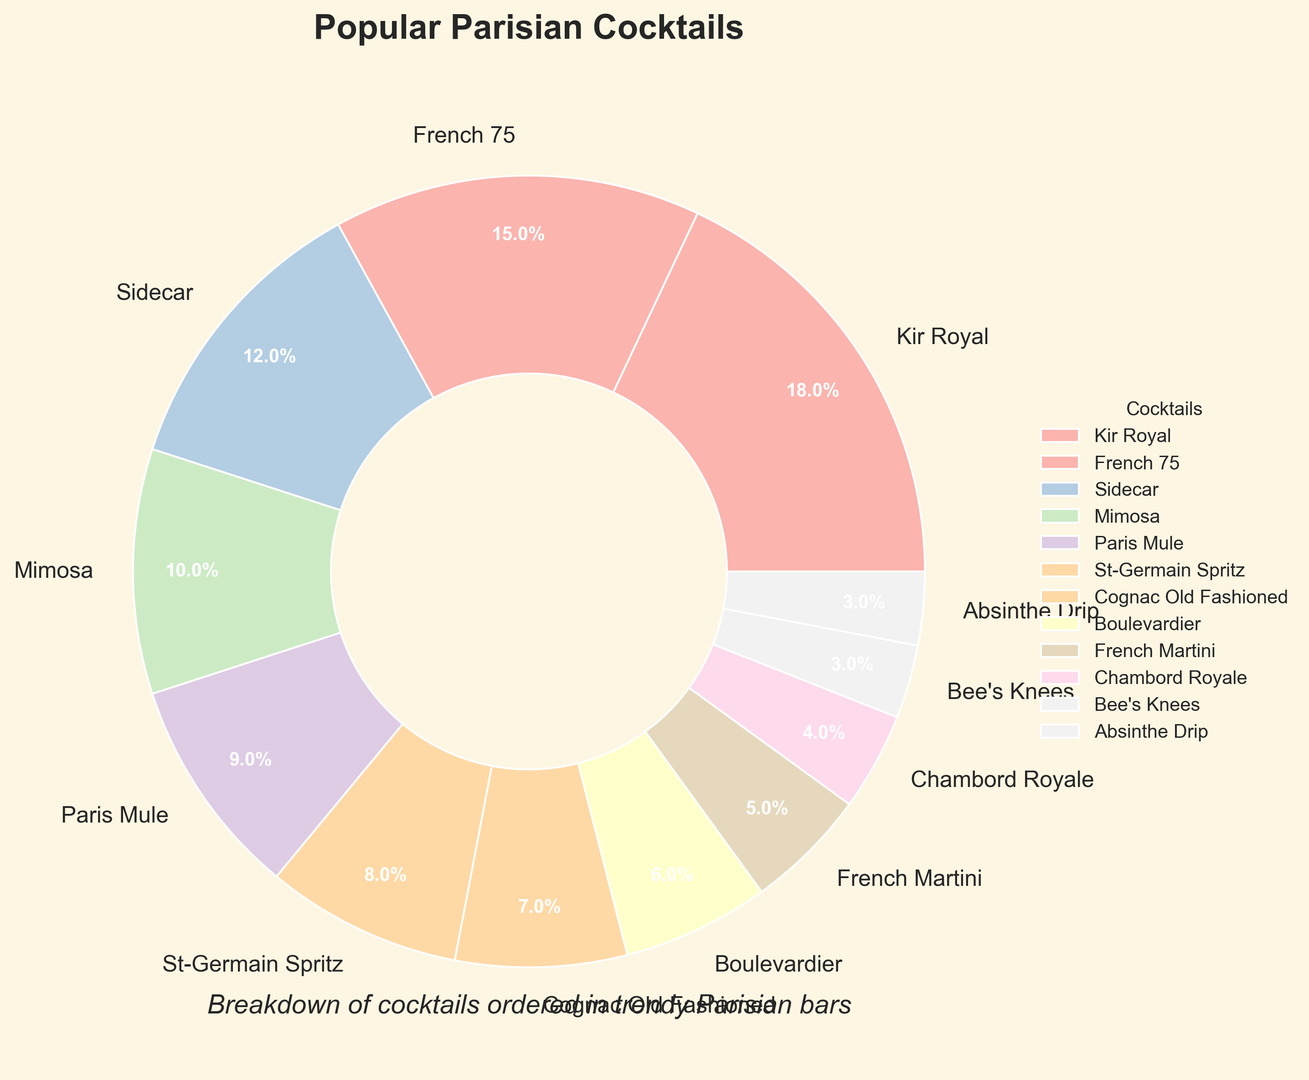Which cocktail has the highest percentage in the pie chart? The highest percentage in the pie chart is the largest slice, which corresponds to the cocktail labeled "Kir Royal" with 18%.
Answer: Kir Royal What is the total percentage of orders for "French 75" and "Sidecar"? Add the percentages of "French 75" and "Sidecar": 15% (French 75) + 12% (Sidecar) = 27%.
Answer: 27% Which two cocktails, when combined, have a total percentage greater than "Kir Royal"? "French 75" and "Sidecar" combined have a total of 27%, which is greater than "Kir Royal's" 18%. Similarly, "Mimosa" and "Paris Mule" combined have a total of 19%, also greater than "Kir Royal."
Answer: French 75 and Sidecar, Mimosa and Paris Mule Is the percentage of "Paris Mule" orders greater than that of "St-Germain Spritz"? The pie chart shows "Paris Mule" at 9% and "St-Germain Spritz" at 8%, so 9% is greater than 8%.
Answer: Yes How many cocktails have a percentage of less than 5%? The slices with percentages less than 5% are labeled "French Martini" (5%), "Chambord Royale" (4%), "Bee's Knees" (3%), and "Absinthe Drip" (3%), summing to four cocktails.
Answer: Four Which cocktail has the smallest slice in the pie chart, and what is its percentage? The smallest slice corresponds to "Absinthe Drip," which is labeled as 3%.
Answer: Absinthe Drip, 3% What is the combined percentage of all cocktails ordered less than 10%? Sum the percentages of "Paris Mule" (9%), "St-Germain Spritz" (8%), "Cognac Old Fashioned" (7%), "Boulevardier" (6%), "French Martini" (5%), "Chambord Royale" (4%), "Bee's Knees" (3%), and "Absinthe Drip" (3%): 9+8+7+6+5+4+3+3 = 45%.
Answer: 45% Are there more cocktails with percentages above 10% or below 10%? And by how many? Count the number of cocktails above 10% (Kir Royal, French 75, and Sidecar, which makes 3) and those below 10% (Mimosa, Paris Mule, St-Germain Spritz, Cognac Old Fashioned, Boulevardier, French Martini, Chambord Royale, Bee's Knees, Absinthe Drip, which makes 9). There are 9 below and 3 above, so there are 6 more cocktails below 10%.
Answer: Below 10%, by 6 What is the difference in percentage between "Kir Royal" and "Cognac Old Fashioned"? Subtract the percentage of "Cognac Old Fashioned" (7%) from "Kir Royal" (18%): 18% - 7% = 11%.
Answer: 11% Which cocktail orders make up exactly 15% in total? "French 75" alone makes up exactly 15% of the total orders.
Answer: French 75 